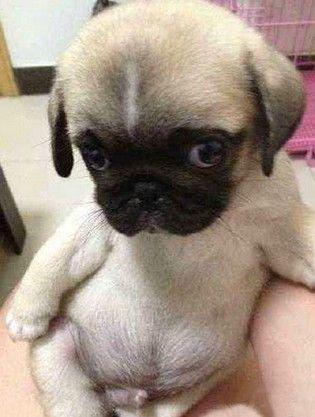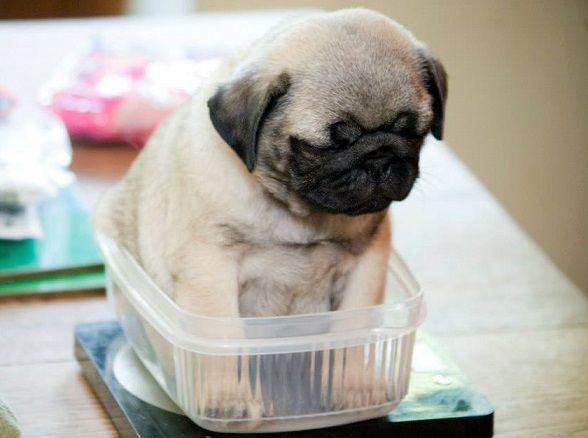The first image is the image on the left, the second image is the image on the right. For the images displayed, is the sentence "puppies are sleeping on their back" factually correct? Answer yes or no. No. The first image is the image on the left, the second image is the image on the right. For the images shown, is this caption "One white dog and one brown dog are sleeping." true? Answer yes or no. No. 